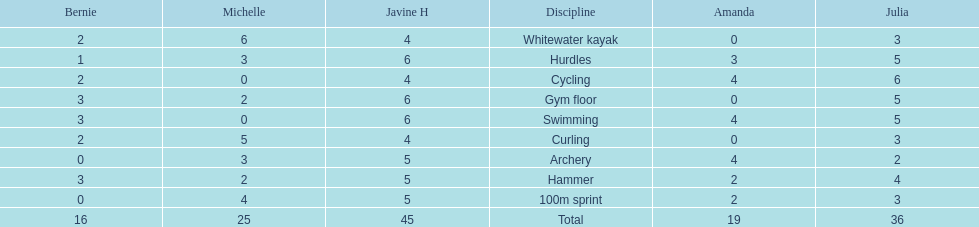Can you parse all the data within this table? {'header': ['Bernie', 'Michelle', 'Javine H', 'Discipline', 'Amanda', 'Julia'], 'rows': [['2', '6', '4', 'Whitewater kayak', '0', '3'], ['1', '3', '6', 'Hurdles', '3', '5'], ['2', '0', '4', 'Cycling', '4', '6'], ['3', '2', '6', 'Gym floor', '0', '5'], ['3', '0', '6', 'Swimming', '4', '5'], ['2', '5', '4', 'Curling', '0', '3'], ['0', '3', '5', 'Archery', '4', '2'], ['3', '2', '5', 'Hammer', '2', '4'], ['0', '4', '5', '100m sprint', '2', '3'], ['16', '25', '45', 'Total', '19', '36']]} Who scored the least on whitewater kayak? Amanda. 